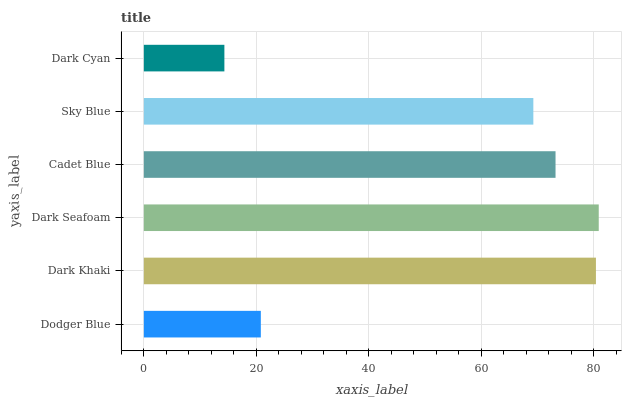Is Dark Cyan the minimum?
Answer yes or no. Yes. Is Dark Seafoam the maximum?
Answer yes or no. Yes. Is Dark Khaki the minimum?
Answer yes or no. No. Is Dark Khaki the maximum?
Answer yes or no. No. Is Dark Khaki greater than Dodger Blue?
Answer yes or no. Yes. Is Dodger Blue less than Dark Khaki?
Answer yes or no. Yes. Is Dodger Blue greater than Dark Khaki?
Answer yes or no. No. Is Dark Khaki less than Dodger Blue?
Answer yes or no. No. Is Cadet Blue the high median?
Answer yes or no. Yes. Is Sky Blue the low median?
Answer yes or no. Yes. Is Dark Cyan the high median?
Answer yes or no. No. Is Dark Cyan the low median?
Answer yes or no. No. 